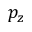Convert formula to latex. <formula><loc_0><loc_0><loc_500><loc_500>p _ { z }</formula> 